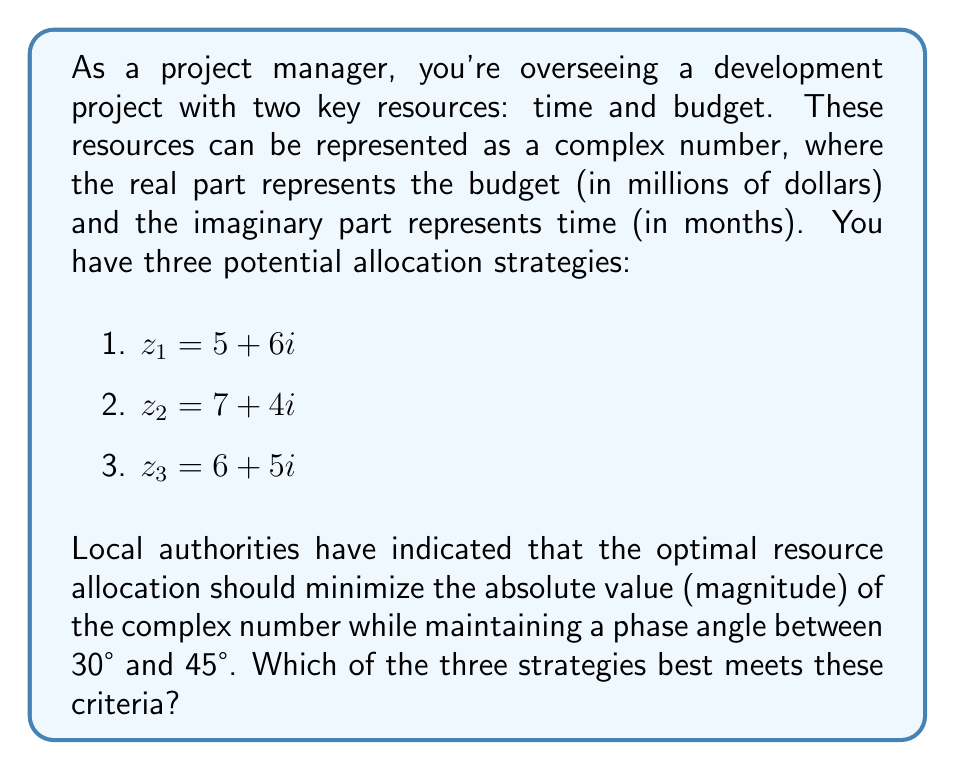Solve this math problem. To solve this problem, we need to calculate the magnitude and phase angle for each complex number and compare them:

1. For $z_1 = 5 + 6i$:
   Magnitude: $|z_1| = \sqrt{5^2 + 6^2} = \sqrt{61} \approx 7.81$
   Phase angle: $\theta_1 = \tan^{-1}(\frac{6}{5}) \approx 50.19°$

2. For $z_2 = 7 + 4i$:
   Magnitude: $|z_2| = \sqrt{7^2 + 4^2} = \sqrt{65} \approx 8.06$
   Phase angle: $\theta_2 = \tan^{-1}(\frac{4}{7}) \approx 29.74°$

3. For $z_3 = 6 + 5i$:
   Magnitude: $|z_3| = \sqrt{6^2 + 5^2} = \sqrt{61} \approx 7.81$
   Phase angle: $\theta_3 = \tan^{-1}(\frac{5}{6}) \approx 39.81°$

Comparing these results:
- $z_1$ has the lowest magnitude (tied with $z_3$), but its phase angle is outside the required range.
- $z_2$ has the highest magnitude and its phase angle is slightly below the required range.
- $z_3$ has the lowest magnitude (tied with $z_1$) and its phase angle is within the required range.

Therefore, $z_3$ is the optimal resource allocation strategy as it minimizes the absolute value while maintaining a phase angle between 30° and 45°.
Answer: The optimal resource allocation strategy is $z_3 = 6 + 5i$, with a magnitude of approximately 7.81 and a phase angle of approximately 39.81°. 